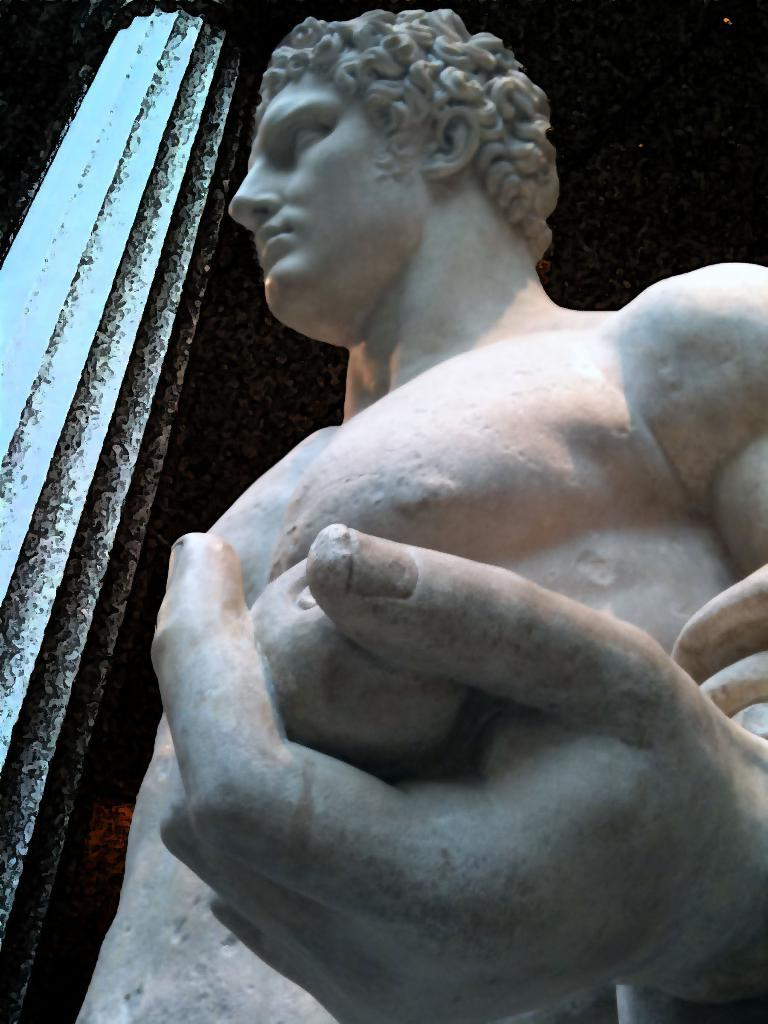What is the main subject of the image? There is a sculpture in the image. Are there any other structures or objects in the image? Yes, there is a pillar in the image. What can be observed about the background of the image? The background of the image is dark. What year is depicted in the sculpture in the image? There is no specific year depicted in the sculpture; it is a visual representation of an object or concept. Is there a bridge visible in the image? No, there is no bridge present in the image. 